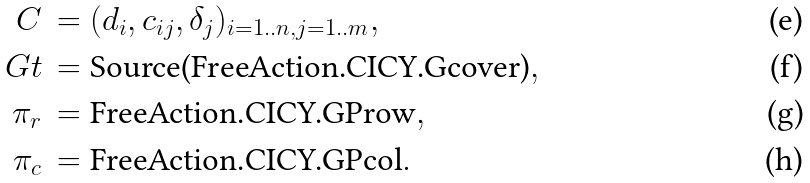Convert formula to latex. <formula><loc_0><loc_0><loc_500><loc_500>C \, & = ( d _ { i } , c _ { i j } , \delta _ { j } ) _ { i = 1 . . n , j = 1 . . m } , \\ \ G t \, & = \text {Source(FreeAction.CICY.Gcover)} , \\ \pi _ { r } \, & = \text {FreeAction.CICY.GProw} , \\ \pi _ { c } \, & = \text {FreeAction.CICY.GPcol} .</formula> 